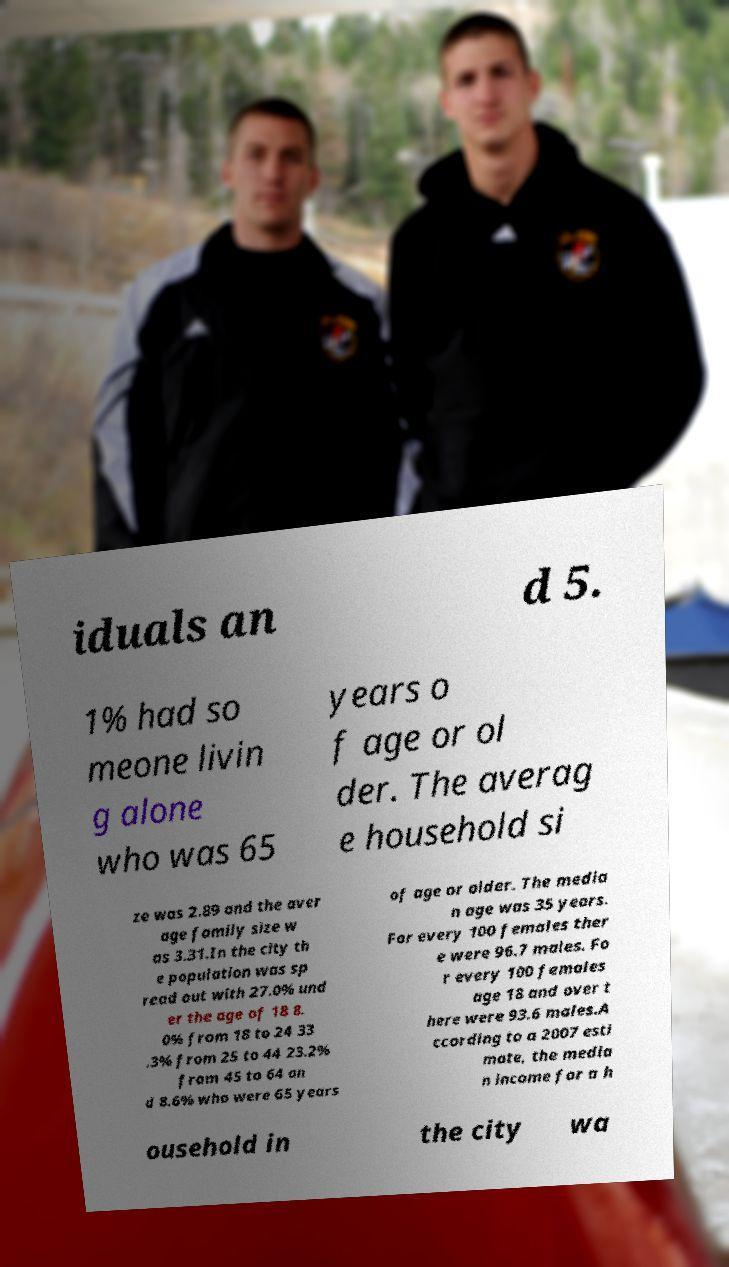There's text embedded in this image that I need extracted. Can you transcribe it verbatim? iduals an d 5. 1% had so meone livin g alone who was 65 years o f age or ol der. The averag e household si ze was 2.89 and the aver age family size w as 3.31.In the city th e population was sp read out with 27.0% und er the age of 18 8. 0% from 18 to 24 33 .3% from 25 to 44 23.2% from 45 to 64 an d 8.6% who were 65 years of age or older. The media n age was 35 years. For every 100 females ther e were 96.7 males. Fo r every 100 females age 18 and over t here were 93.6 males.A ccording to a 2007 esti mate, the media n income for a h ousehold in the city wa 